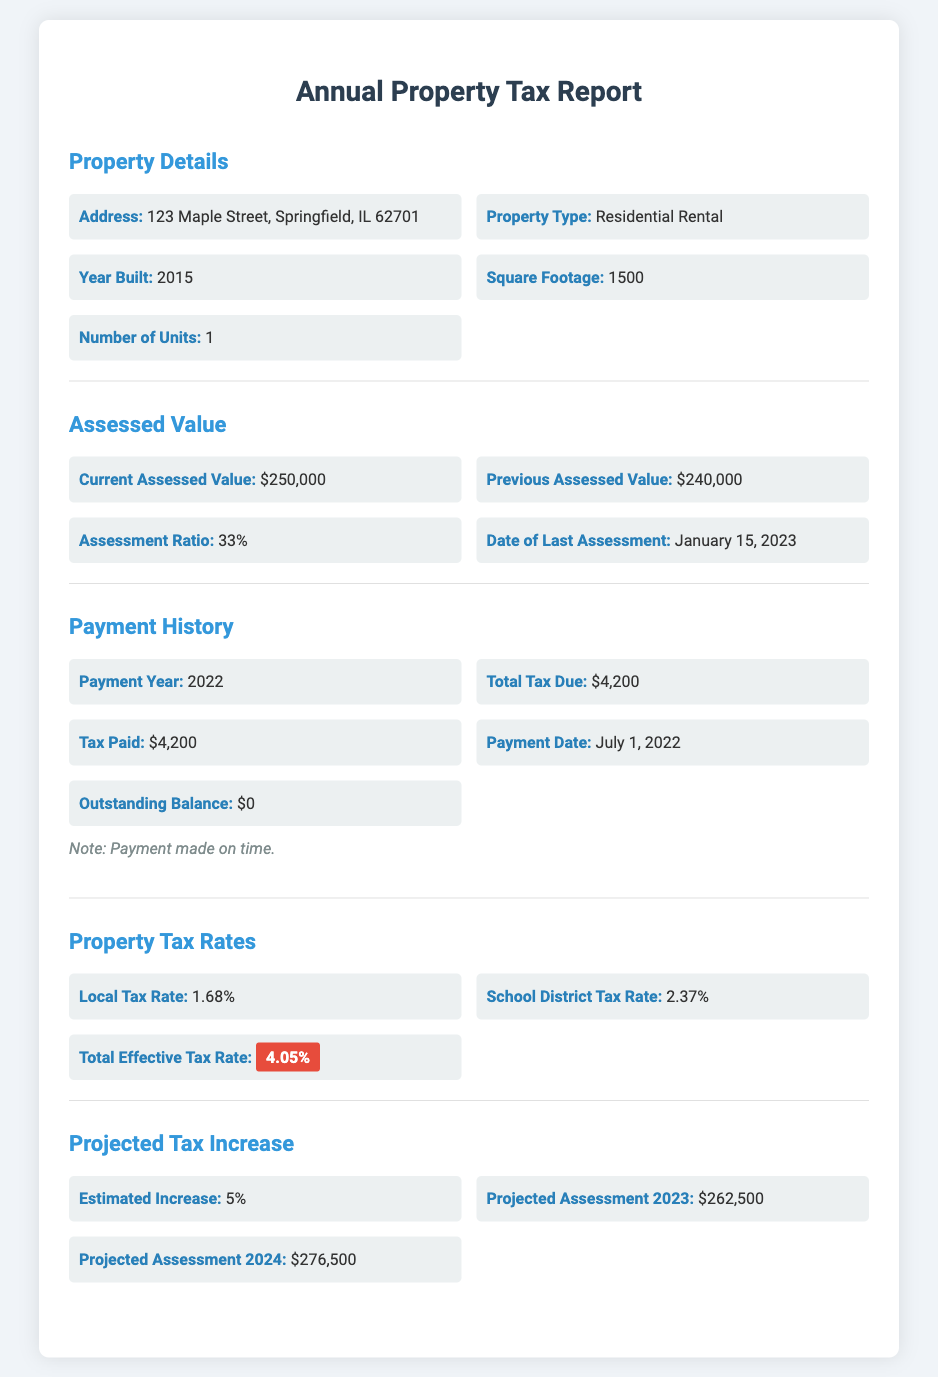What is the current assessed value? The current assessed value is stated in the document as $250,000.
Answer: $250,000 What was the total tax due for the year 2022? The document specifies that the total tax due for the year 2022 was $4,200.
Answer: $4,200 What is the local tax rate? The local tax rate given in the document is 1.68%.
Answer: 1.68% When was the last assessment date? The document mentions that the date of the last assessment was January 15, 2023.
Answer: January 15, 2023 What is the projected assessment for 2024? According to the document, the projected assessment for 2024 is $276,500.
Answer: $276,500 How much tax was paid for the year 2022? The document states that the tax paid for the year 2022 was $4,200.
Answer: $4,200 What is the estimated increase in property tax? The estimated increase in property tax is noted as 5% in the document.
Answer: 5% What is the outstanding balance reported? The document indicates that the outstanding balance is $0.
Answer: $0 What is the assessment ratio mentioned? The assessment ratio provided in the document is 33%.
Answer: 33% 